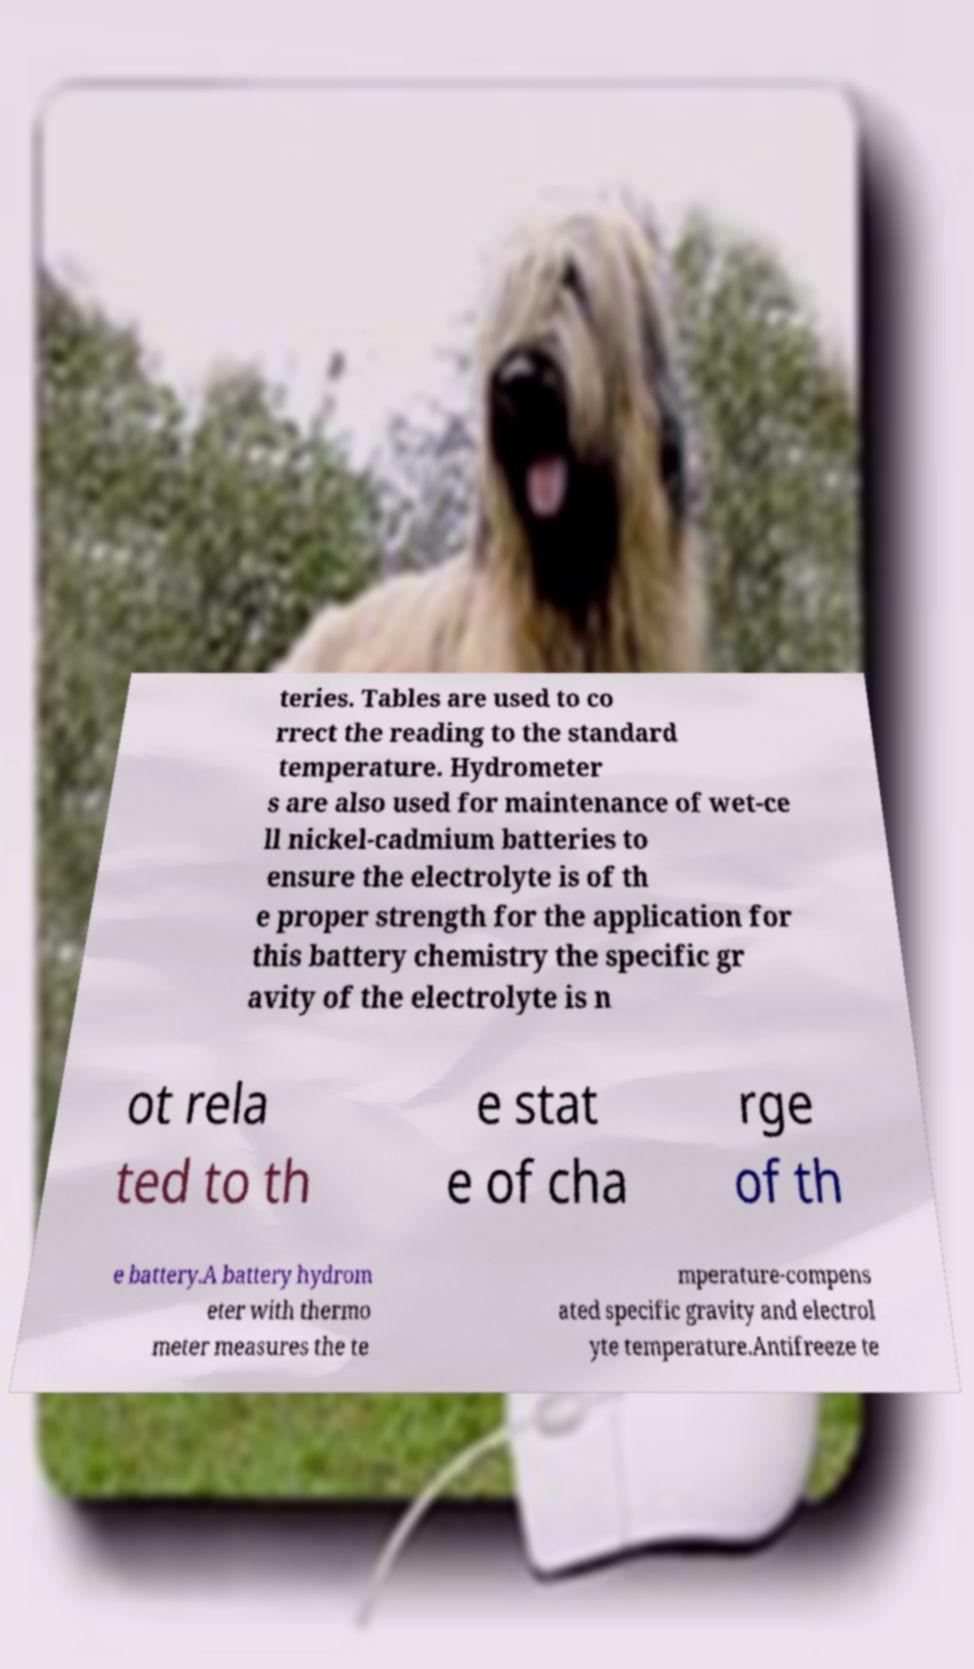I need the written content from this picture converted into text. Can you do that? teries. Tables are used to co rrect the reading to the standard temperature. Hydrometer s are also used for maintenance of wet-ce ll nickel-cadmium batteries to ensure the electrolyte is of th e proper strength for the application for this battery chemistry the specific gr avity of the electrolyte is n ot rela ted to th e stat e of cha rge of th e battery.A battery hydrom eter with thermo meter measures the te mperature-compens ated specific gravity and electrol yte temperature.Antifreeze te 